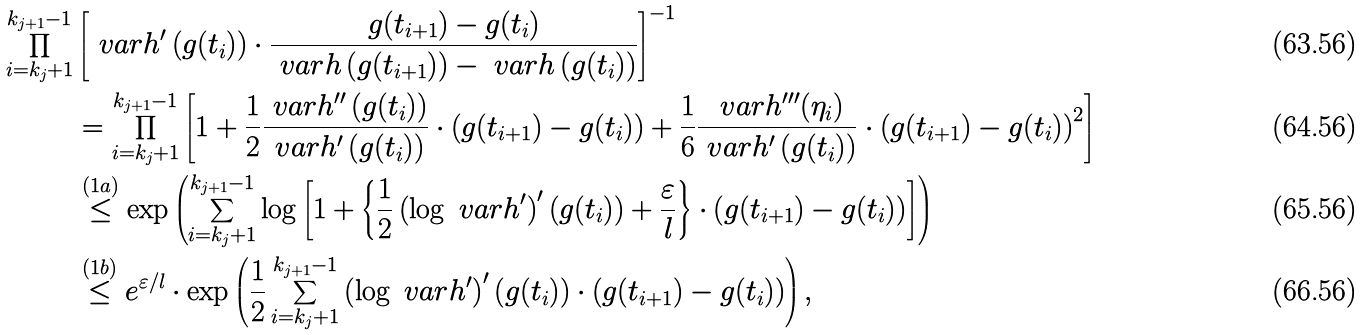<formula> <loc_0><loc_0><loc_500><loc_500>\prod ^ { k _ { j + 1 } - 1 } _ { i = k _ { j } + 1 } & \left [ \ v a r h ^ { \prime } \left ( g ( t _ { i } ) \right ) \cdot \frac { g ( t _ { i + 1 } ) - g ( t _ { i } ) } { \ v a r h \left ( g ( t _ { i + 1 } ) \right ) - \ v a r h \left ( g ( t _ { i } ) \right ) } \right ] ^ { - 1 } \\ & = \prod ^ { k _ { j + 1 } - 1 } _ { i = k _ { j } + 1 } \left [ 1 + \frac { 1 } { 2 } \frac { \ v a r h ^ { \prime \prime } \left ( g ( t _ { i } ) \right ) } { \ v a r h ^ { \prime } \left ( g ( t _ { i } ) \right ) } \cdot \left ( g ( t _ { i + 1 } ) - g ( t _ { i } ) \right ) + \frac { 1 } { 6 } \frac { \ v a r h ^ { \prime \prime \prime } ( \eta _ { i } ) } { \ v a r h ^ { \prime } \left ( g ( t _ { i } ) \right ) } \cdot \left ( g ( t _ { i + 1 } ) - g ( t _ { i } ) \right ) ^ { 2 } \right ] \\ & \overset { ( 1 a ) } { \leq } \exp \left ( \sum ^ { k _ { j + 1 } - 1 } _ { i = k _ { j } + 1 } \log \left [ 1 + \left \{ \frac { 1 } { 2 } \left ( \log \ v a r h ^ { \prime } \right ) ^ { \prime } \left ( g ( t _ { i } ) \right ) + \frac { \varepsilon } { l } \right \} \cdot \left ( g ( t _ { i + 1 } ) - g ( t _ { i } ) \right ) \right ] \right ) \\ & \overset { ( 1 b ) } { \leq } e ^ { \varepsilon / l } \cdot \exp \left ( \frac { 1 } { 2 } \sum ^ { k _ { j + 1 } - 1 } _ { i = k _ { j } + 1 } \left ( \log \ v a r h ^ { \prime } \right ) ^ { \prime } \left ( g ( t _ { i } ) \right ) \cdot \left ( g ( t _ { i + 1 } ) - g ( t _ { i } ) \right ) \right ) ,</formula> 